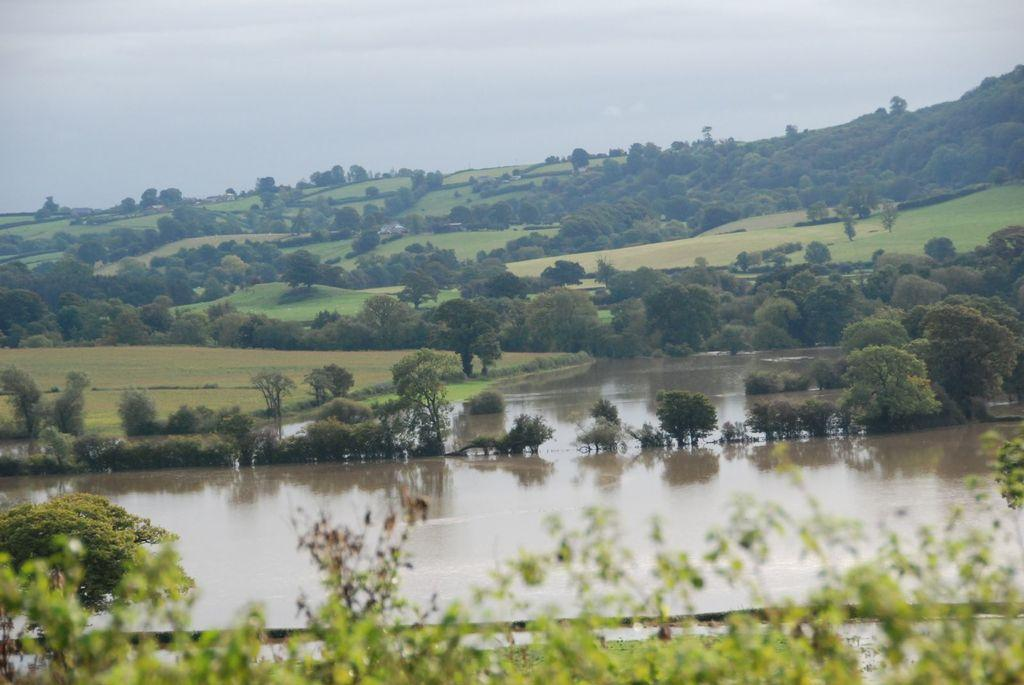What is the main element in the center of the image? There is water in the center of the image. What type of vegetation is present at the bottom of the image? There is grass on the surface at the bottom of the image. What can be seen in the background of the image? There are trees and the sky visible in the background of the image. Where is the toothbrush hidden in the image? There is no toothbrush present in the image. How many bushes are there in the image? The image does not specify the number of bushes, as it only mentions trees in the background. 